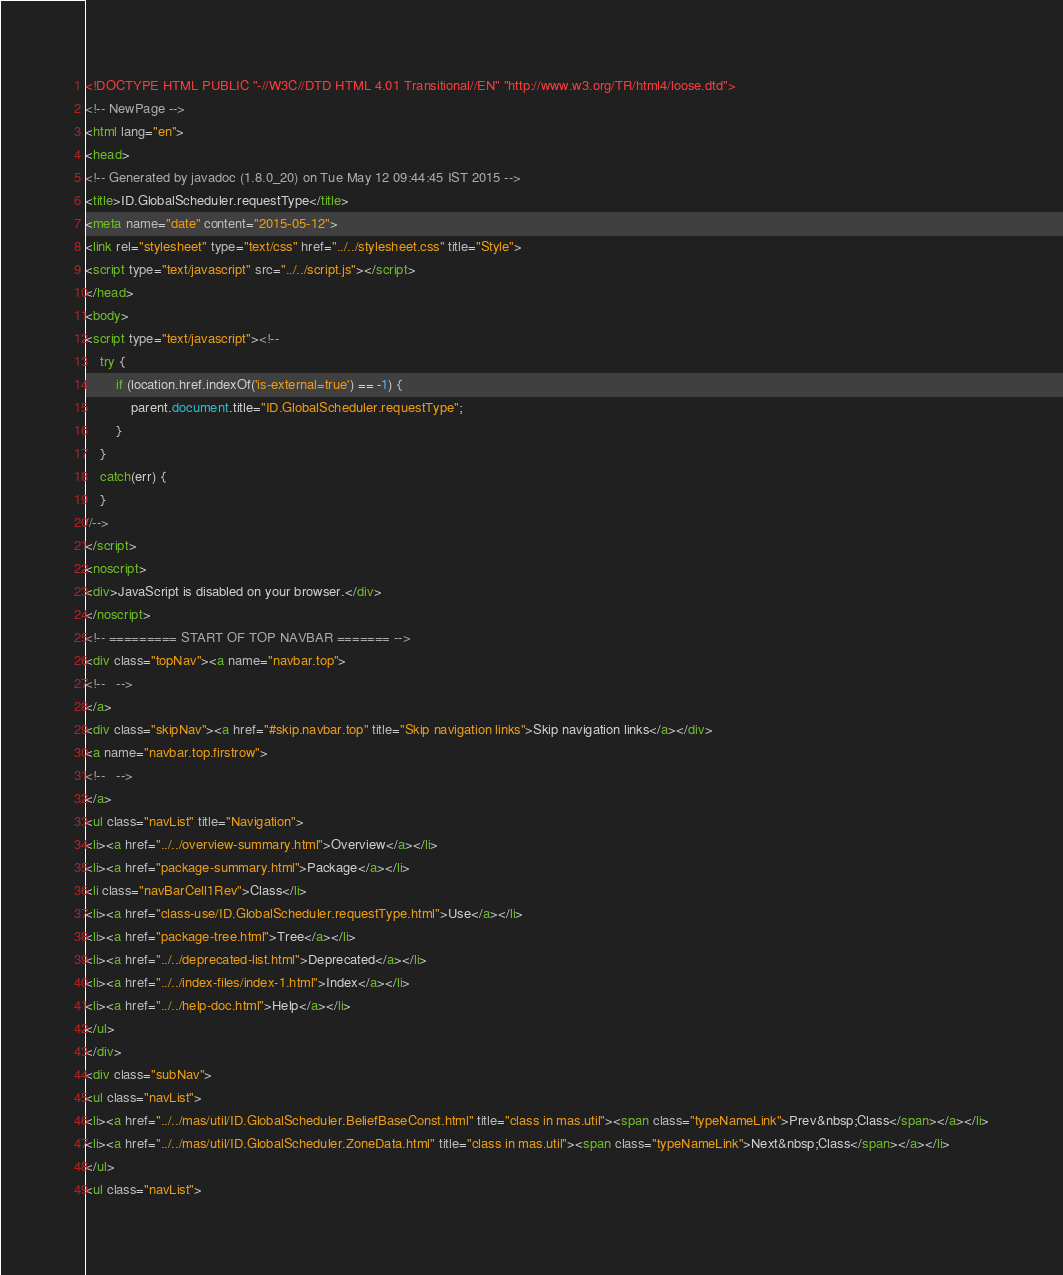Convert code to text. <code><loc_0><loc_0><loc_500><loc_500><_HTML_><!DOCTYPE HTML PUBLIC "-//W3C//DTD HTML 4.01 Transitional//EN" "http://www.w3.org/TR/html4/loose.dtd">
<!-- NewPage -->
<html lang="en">
<head>
<!-- Generated by javadoc (1.8.0_20) on Tue May 12 09:44:45 IST 2015 -->
<title>ID.GlobalScheduler.requestType</title>
<meta name="date" content="2015-05-12">
<link rel="stylesheet" type="text/css" href="../../stylesheet.css" title="Style">
<script type="text/javascript" src="../../script.js"></script>
</head>
<body>
<script type="text/javascript"><!--
    try {
        if (location.href.indexOf('is-external=true') == -1) {
            parent.document.title="ID.GlobalScheduler.requestType";
        }
    }
    catch(err) {
    }
//-->
</script>
<noscript>
<div>JavaScript is disabled on your browser.</div>
</noscript>
<!-- ========= START OF TOP NAVBAR ======= -->
<div class="topNav"><a name="navbar.top">
<!--   -->
</a>
<div class="skipNav"><a href="#skip.navbar.top" title="Skip navigation links">Skip navigation links</a></div>
<a name="navbar.top.firstrow">
<!--   -->
</a>
<ul class="navList" title="Navigation">
<li><a href="../../overview-summary.html">Overview</a></li>
<li><a href="package-summary.html">Package</a></li>
<li class="navBarCell1Rev">Class</li>
<li><a href="class-use/ID.GlobalScheduler.requestType.html">Use</a></li>
<li><a href="package-tree.html">Tree</a></li>
<li><a href="../../deprecated-list.html">Deprecated</a></li>
<li><a href="../../index-files/index-1.html">Index</a></li>
<li><a href="../../help-doc.html">Help</a></li>
</ul>
</div>
<div class="subNav">
<ul class="navList">
<li><a href="../../mas/util/ID.GlobalScheduler.BeliefBaseConst.html" title="class in mas.util"><span class="typeNameLink">Prev&nbsp;Class</span></a></li>
<li><a href="../../mas/util/ID.GlobalScheduler.ZoneData.html" title="class in mas.util"><span class="typeNameLink">Next&nbsp;Class</span></a></li>
</ul>
<ul class="navList"></code> 